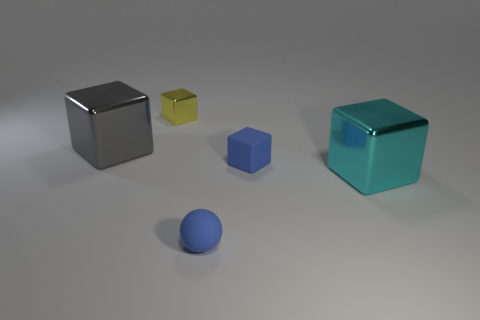What number of other objects are the same color as the small ball?
Make the answer very short. 1. Are there any other things that have the same size as the cyan block?
Offer a very short reply. Yes. There is a metallic object in front of the large gray block; is its shape the same as the small thing behind the big gray cube?
Ensure brevity in your answer.  Yes. What is the shape of the blue thing that is the same size as the blue rubber cube?
Your answer should be very brief. Sphere. Are there an equal number of shiny things that are to the left of the small yellow thing and big objects that are behind the tiny blue matte sphere?
Make the answer very short. No. Is there anything else that is the same shape as the gray thing?
Your answer should be compact. Yes. Does the blue object behind the small blue rubber sphere have the same material as the big gray block?
Give a very brief answer. No. What material is the blue sphere that is the same size as the yellow cube?
Your answer should be compact. Rubber. What number of other objects are there of the same material as the blue cube?
Keep it short and to the point. 1. There is a sphere; is it the same size as the metal thing that is on the left side of the yellow shiny cube?
Provide a succinct answer. No. 